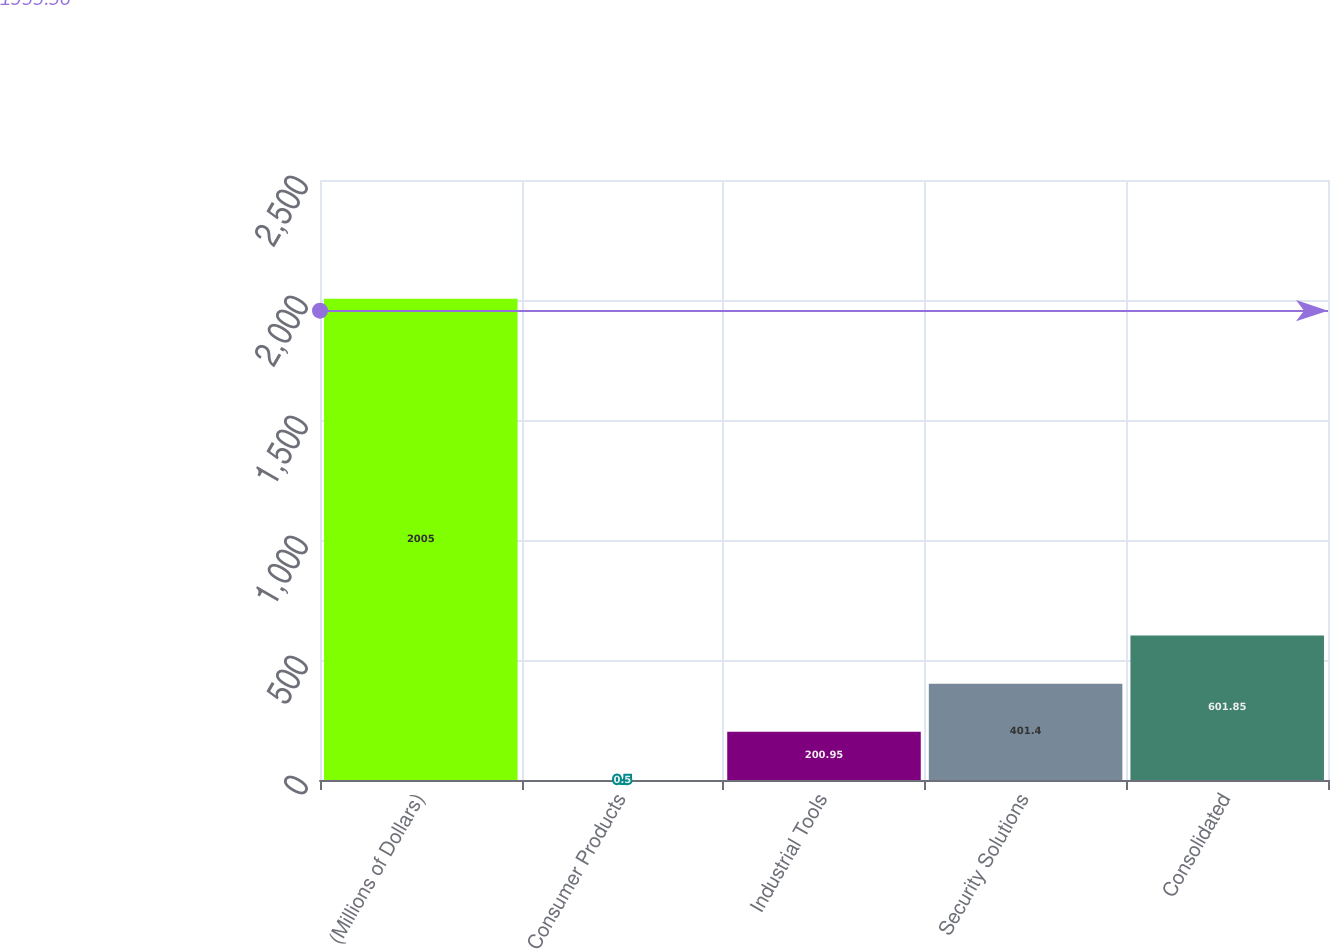Convert chart. <chart><loc_0><loc_0><loc_500><loc_500><bar_chart><fcel>(Millions of Dollars)<fcel>Consumer Products<fcel>Industrial Tools<fcel>Security Solutions<fcel>Consolidated<nl><fcel>2005<fcel>0.5<fcel>200.95<fcel>401.4<fcel>601.85<nl></chart> 